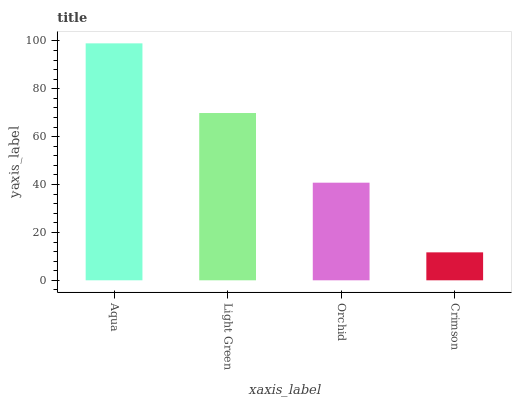Is Crimson the minimum?
Answer yes or no. Yes. Is Aqua the maximum?
Answer yes or no. Yes. Is Light Green the minimum?
Answer yes or no. No. Is Light Green the maximum?
Answer yes or no. No. Is Aqua greater than Light Green?
Answer yes or no. Yes. Is Light Green less than Aqua?
Answer yes or no. Yes. Is Light Green greater than Aqua?
Answer yes or no. No. Is Aqua less than Light Green?
Answer yes or no. No. Is Light Green the high median?
Answer yes or no. Yes. Is Orchid the low median?
Answer yes or no. Yes. Is Aqua the high median?
Answer yes or no. No. Is Aqua the low median?
Answer yes or no. No. 